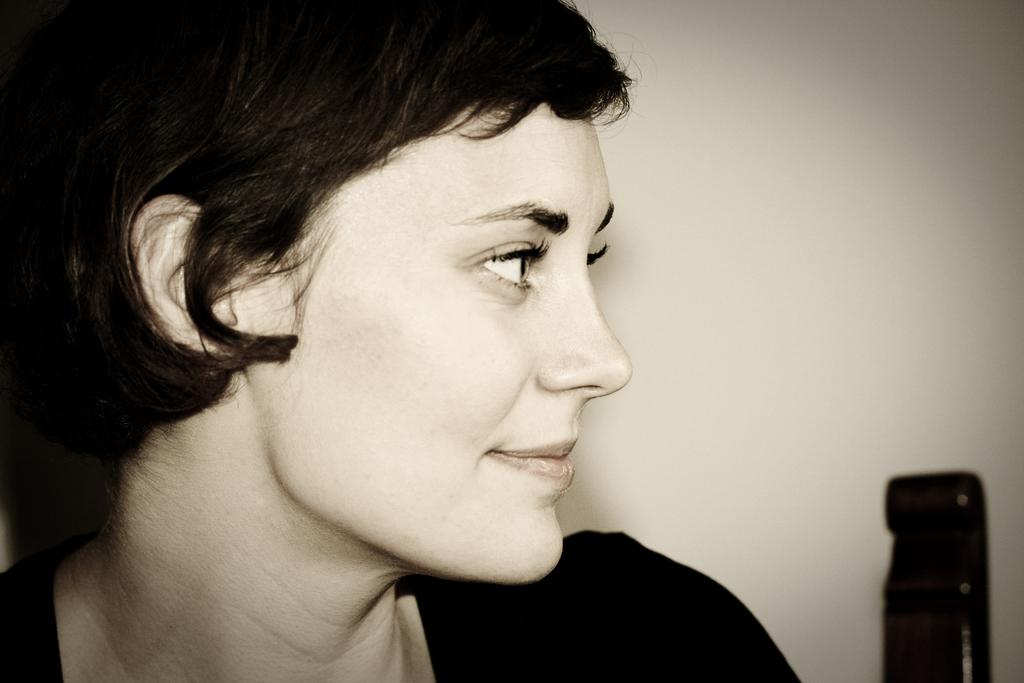Who is the main subject in the image? There is a woman in the center of the image. What is the woman's expression in the image? The woman is smiling. What can be seen in the background of the image? There is a wall and a black color object in the background of the image. What type of breakfast is the woman eating in the image? There is no breakfast visible in the image; it only shows a woman smiling with a wall and a black color object in the background. How many frogs are present in the image? There are no frogs present in the image. 